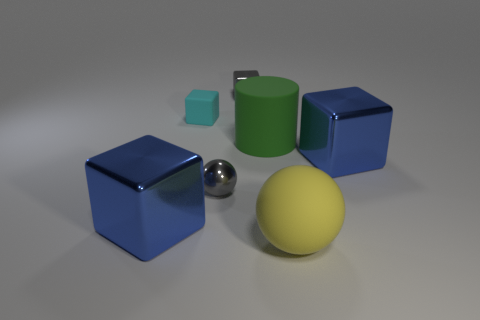What color is the large metal block that is behind the gray object that is in front of the tiny cyan thing?
Offer a very short reply. Blue. Are there fewer large yellow matte balls that are behind the large yellow thing than big blue things that are to the right of the tiny gray sphere?
Offer a terse response. Yes. There is a cube that is the same color as the metallic sphere; what is its material?
Your response must be concise. Metal. What number of objects are large metal objects left of the yellow matte object or big blue rubber cubes?
Provide a succinct answer. 1. There is a blue object on the left side of the matte ball; does it have the same size as the large green cylinder?
Provide a succinct answer. Yes. Are there fewer green rubber objects that are right of the big sphere than tiny green metallic blocks?
Offer a very short reply. No. What is the material of the sphere that is the same size as the rubber block?
Make the answer very short. Metal. How many large things are green cylinders or metal cubes?
Ensure brevity in your answer.  3. How many things are either big matte objects to the right of the green matte cylinder or cubes left of the large yellow ball?
Provide a short and direct response. 4. Are there fewer small matte objects than cyan metal objects?
Keep it short and to the point. No. 